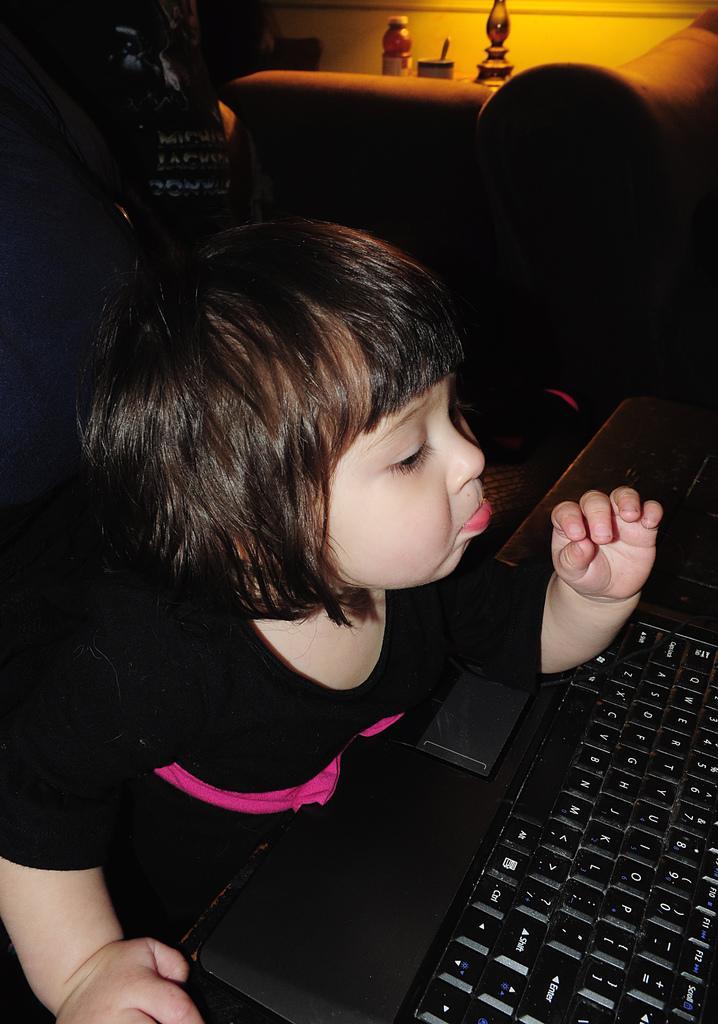Could you give a brief overview of what you see in this image? In the given image i can see a girl,key board and behind her i can see some objects. 